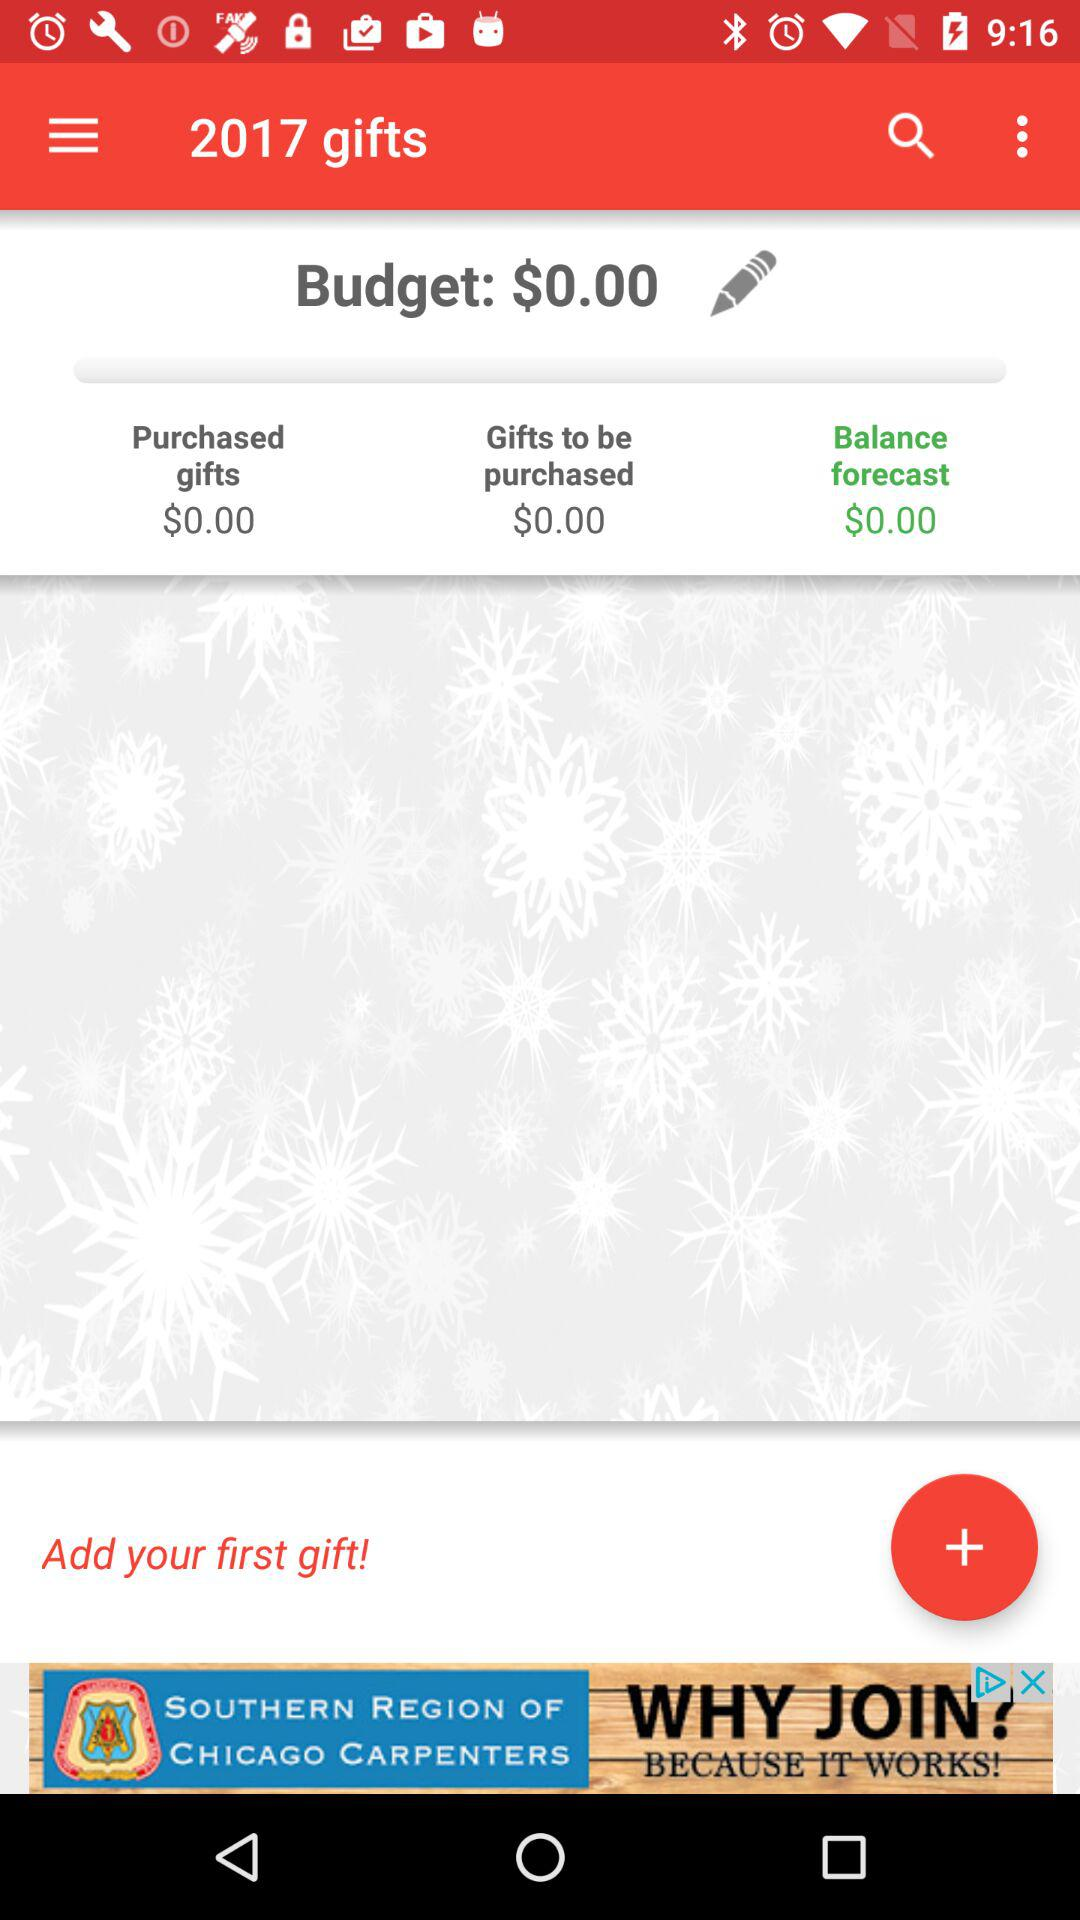How much is the balance forecast amount? The balance forecast amount is $0. 